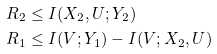Convert formula to latex. <formula><loc_0><loc_0><loc_500><loc_500>R _ { 2 } & \leq I ( X _ { 2 } , U ; Y _ { 2 } ) \\ R _ { 1 } & \leq I ( V ; Y _ { 1 } ) - I ( V ; X _ { 2 } , U )</formula> 